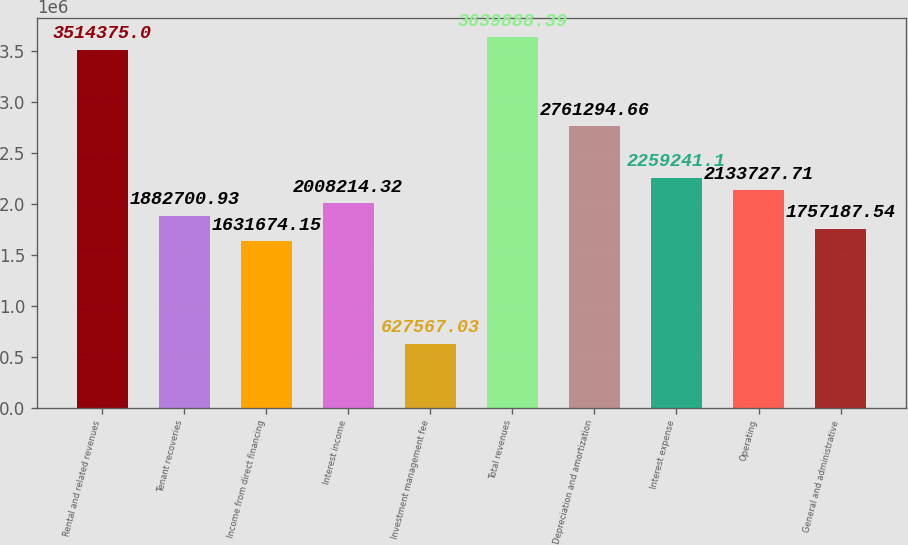Convert chart. <chart><loc_0><loc_0><loc_500><loc_500><bar_chart><fcel>Rental and related revenues<fcel>Tenant recoveries<fcel>Income from direct financing<fcel>Interest income<fcel>Investment management fee<fcel>Total revenues<fcel>Depreciation and amortization<fcel>Interest expense<fcel>Operating<fcel>General and administrative<nl><fcel>3.51438e+06<fcel>1.8827e+06<fcel>1.63167e+06<fcel>2.00821e+06<fcel>627567<fcel>3.63989e+06<fcel>2.76129e+06<fcel>2.25924e+06<fcel>2.13373e+06<fcel>1.75719e+06<nl></chart> 